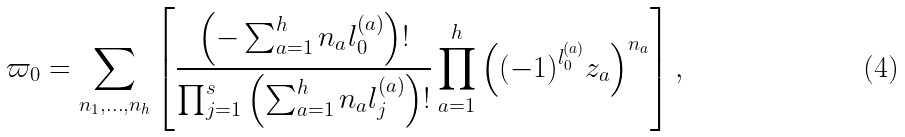Convert formula to latex. <formula><loc_0><loc_0><loc_500><loc_500>\varpi _ { 0 } = \sum _ { n _ { 1 } , \dots , n _ { h } } \left [ \frac { \left ( - \sum _ { a = 1 } ^ { h } n _ { a } l _ { 0 } ^ { ( a ) } \right ) ! } { \prod _ { j = 1 } ^ { s } \left ( \sum _ { a = 1 } ^ { h } n _ { a } l _ { j } ^ { ( a ) } \right ) ! } \prod _ { a = 1 } ^ { h } \left ( ( - 1 ) ^ { l _ { 0 } ^ { ( a ) } } z _ { a } \right ) ^ { n _ { a } } \right ] ,</formula> 